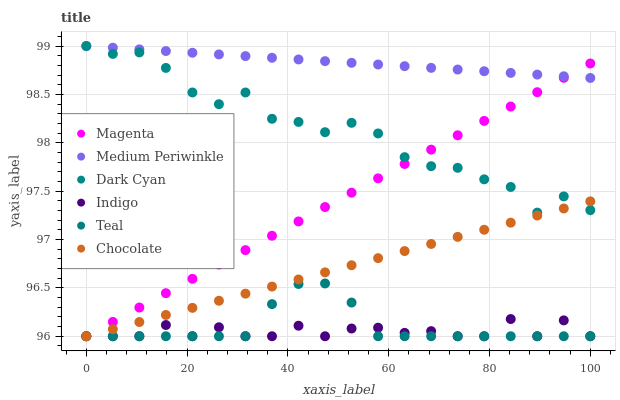Does Indigo have the minimum area under the curve?
Answer yes or no. Yes. Does Medium Periwinkle have the maximum area under the curve?
Answer yes or no. Yes. Does Chocolate have the minimum area under the curve?
Answer yes or no. No. Does Chocolate have the maximum area under the curve?
Answer yes or no. No. Is Medium Periwinkle the smoothest?
Answer yes or no. Yes. Is Dark Cyan the roughest?
Answer yes or no. Yes. Is Chocolate the smoothest?
Answer yes or no. No. Is Chocolate the roughest?
Answer yes or no. No. Does Indigo have the lowest value?
Answer yes or no. Yes. Does Medium Periwinkle have the lowest value?
Answer yes or no. No. Does Dark Cyan have the highest value?
Answer yes or no. Yes. Does Chocolate have the highest value?
Answer yes or no. No. Is Teal less than Dark Cyan?
Answer yes or no. Yes. Is Medium Periwinkle greater than Indigo?
Answer yes or no. Yes. Does Chocolate intersect Magenta?
Answer yes or no. Yes. Is Chocolate less than Magenta?
Answer yes or no. No. Is Chocolate greater than Magenta?
Answer yes or no. No. Does Teal intersect Dark Cyan?
Answer yes or no. No. 